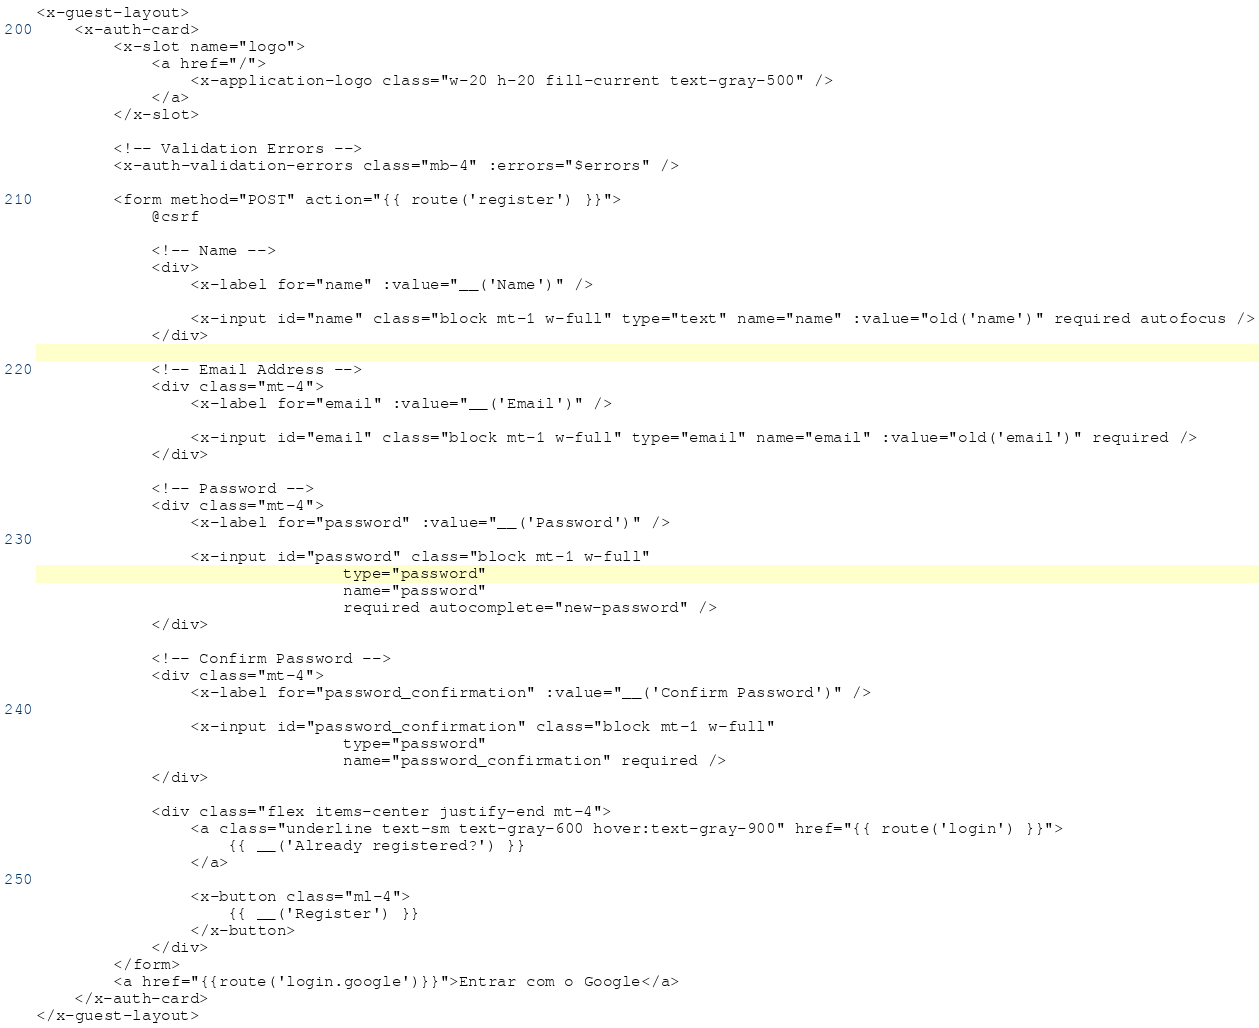<code> <loc_0><loc_0><loc_500><loc_500><_PHP_><x-guest-layout>
    <x-auth-card>
        <x-slot name="logo">
            <a href="/">
                <x-application-logo class="w-20 h-20 fill-current text-gray-500" />
            </a>
        </x-slot>

        <!-- Validation Errors -->
        <x-auth-validation-errors class="mb-4" :errors="$errors" />

        <form method="POST" action="{{ route('register') }}">
            @csrf

            <!-- Name -->
            <div>
                <x-label for="name" :value="__('Name')" />

                <x-input id="name" class="block mt-1 w-full" type="text" name="name" :value="old('name')" required autofocus />
            </div>

            <!-- Email Address -->
            <div class="mt-4">
                <x-label for="email" :value="__('Email')" />

                <x-input id="email" class="block mt-1 w-full" type="email" name="email" :value="old('email')" required />
            </div>

            <!-- Password -->
            <div class="mt-4">
                <x-label for="password" :value="__('Password')" />

                <x-input id="password" class="block mt-1 w-full"
                                type="password"
                                name="password"
                                required autocomplete="new-password" />
            </div>

            <!-- Confirm Password -->
            <div class="mt-4">
                <x-label for="password_confirmation" :value="__('Confirm Password')" />

                <x-input id="password_confirmation" class="block mt-1 w-full"
                                type="password"
                                name="password_confirmation" required />
            </div>

            <div class="flex items-center justify-end mt-4">
                <a class="underline text-sm text-gray-600 hover:text-gray-900" href="{{ route('login') }}">
                    {{ __('Already registered?') }}
                </a>

                <x-button class="ml-4">
                    {{ __('Register') }}
                </x-button>
            </div>
        </form>
        <a href="{{route('login.google')}}">Entrar com o Google</a>
    </x-auth-card>
</x-guest-layout>
</code> 